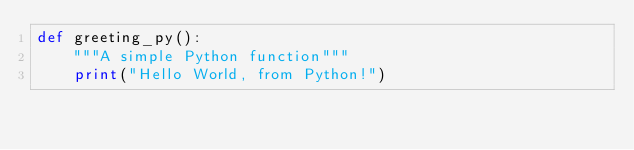<code> <loc_0><loc_0><loc_500><loc_500><_Python_>def greeting_py():
    """A simple Python function"""  
    print("Hello World, from Python!")

</code> 